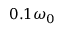<formula> <loc_0><loc_0><loc_500><loc_500>0 . 1 \omega _ { 0 }</formula> 